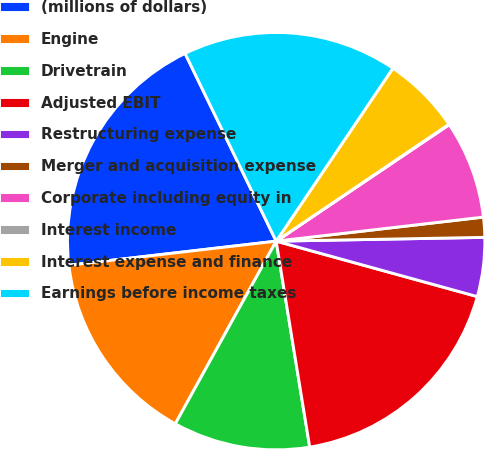Convert chart to OTSL. <chart><loc_0><loc_0><loc_500><loc_500><pie_chart><fcel>(millions of dollars)<fcel>Engine<fcel>Drivetrain<fcel>Adjusted EBIT<fcel>Restructuring expense<fcel>Merger and acquisition expense<fcel>Corporate including equity in<fcel>Interest income<fcel>Interest expense and finance<fcel>Earnings before income taxes<nl><fcel>19.65%<fcel>15.13%<fcel>10.6%<fcel>18.15%<fcel>4.57%<fcel>1.55%<fcel>7.59%<fcel>0.04%<fcel>6.08%<fcel>16.64%<nl></chart> 